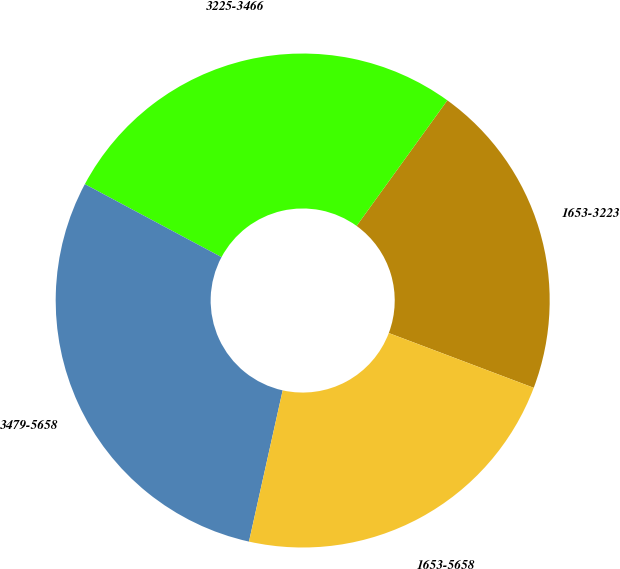Convert chart. <chart><loc_0><loc_0><loc_500><loc_500><pie_chart><fcel>1653-3223<fcel>3225-3466<fcel>3479-5658<fcel>1653-5658<nl><fcel>20.79%<fcel>27.15%<fcel>29.32%<fcel>22.74%<nl></chart> 